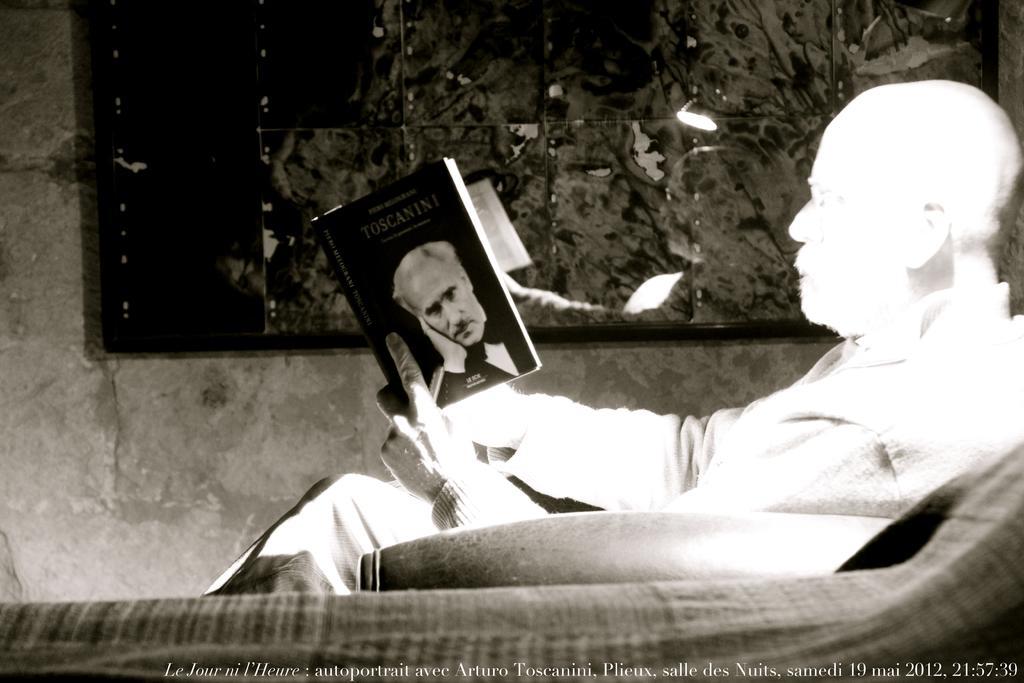Describe this image in one or two sentences. There is a person who is sitting, holding a book and reading. In front of him, there is a watermark. In the background, there is a window, near a wall. Through this window, we can see, there are plants and a light. 